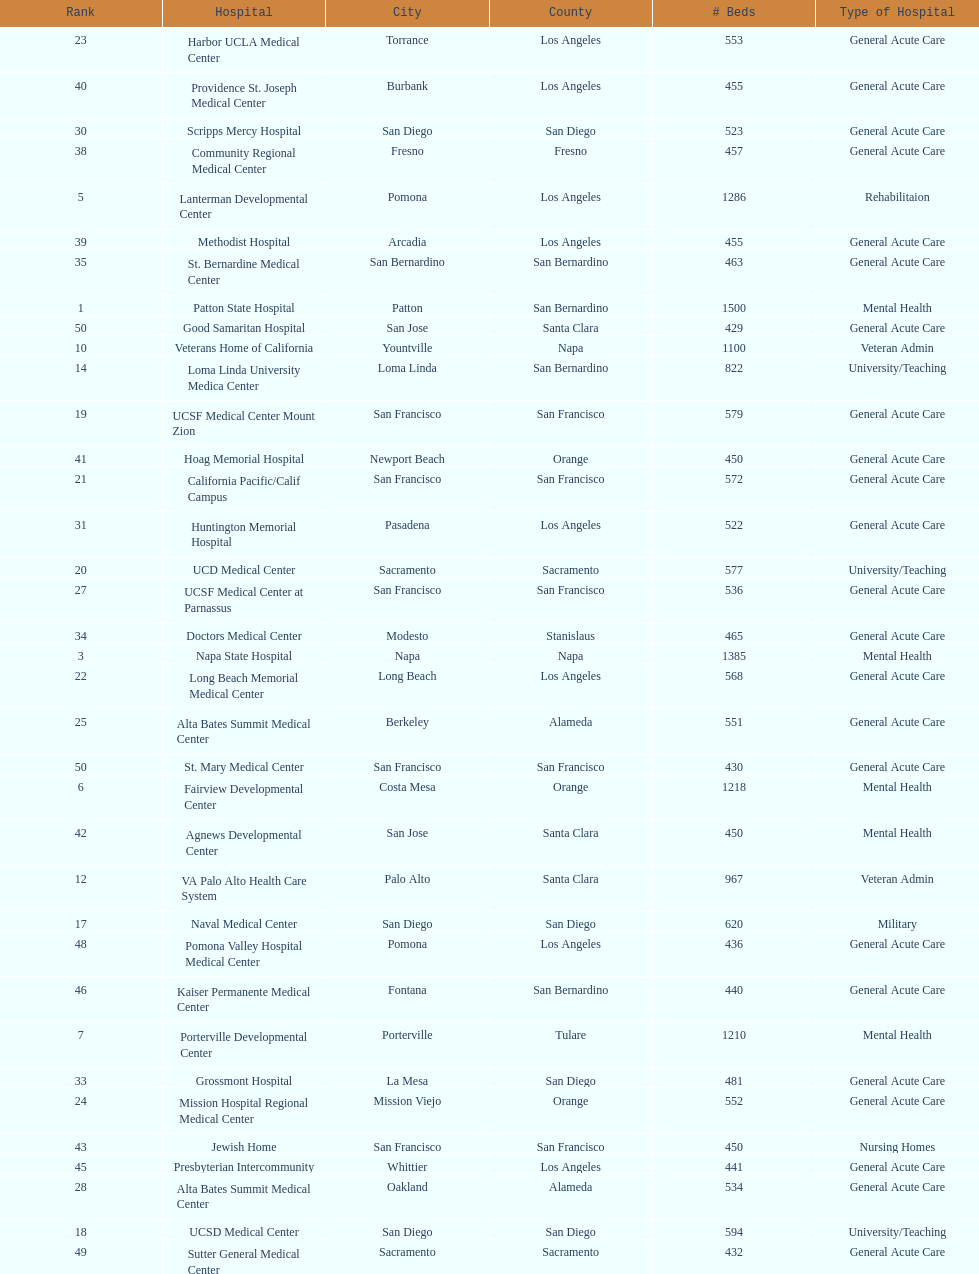Could you parse the entire table as a dict? {'header': ['Rank', 'Hospital', 'City', 'County', '# Beds', 'Type of Hospital'], 'rows': [['23', 'Harbor UCLA Medical Center', 'Torrance', 'Los Angeles', '553', 'General Acute Care'], ['40', 'Providence St. Joseph Medical Center', 'Burbank', 'Los Angeles', '455', 'General Acute Care'], ['30', 'Scripps Mercy Hospital', 'San Diego', 'San Diego', '523', 'General Acute Care'], ['38', 'Community Regional Medical Center', 'Fresno', 'Fresno', '457', 'General Acute Care'], ['5', 'Lanterman Developmental Center', 'Pomona', 'Los Angeles', '1286', 'Rehabilitaion'], ['39', 'Methodist Hospital', 'Arcadia', 'Los Angeles', '455', 'General Acute Care'], ['35', 'St. Bernardine Medical Center', 'San Bernardino', 'San Bernardino', '463', 'General Acute Care'], ['1', 'Patton State Hospital', 'Patton', 'San Bernardino', '1500', 'Mental Health'], ['50', 'Good Samaritan Hospital', 'San Jose', 'Santa Clara', '429', 'General Acute Care'], ['10', 'Veterans Home of California', 'Yountville', 'Napa', '1100', 'Veteran Admin'], ['14', 'Loma Linda University Medica Center', 'Loma Linda', 'San Bernardino', '822', 'University/Teaching'], ['19', 'UCSF Medical Center Mount Zion', 'San Francisco', 'San Francisco', '579', 'General Acute Care'], ['41', 'Hoag Memorial Hospital', 'Newport Beach', 'Orange', '450', 'General Acute Care'], ['21', 'California Pacific/Calif Campus', 'San Francisco', 'San Francisco', '572', 'General Acute Care'], ['31', 'Huntington Memorial Hospital', 'Pasadena', 'Los Angeles', '522', 'General Acute Care'], ['20', 'UCD Medical Center', 'Sacramento', 'Sacramento', '577', 'University/Teaching'], ['27', 'UCSF Medical Center at Parnassus', 'San Francisco', 'San Francisco', '536', 'General Acute Care'], ['34', 'Doctors Medical Center', 'Modesto', 'Stanislaus', '465', 'General Acute Care'], ['3', 'Napa State Hospital', 'Napa', 'Napa', '1385', 'Mental Health'], ['22', 'Long Beach Memorial Medical Center', 'Long Beach', 'Los Angeles', '568', 'General Acute Care'], ['25', 'Alta Bates Summit Medical Center', 'Berkeley', 'Alameda', '551', 'General Acute Care'], ['50', 'St. Mary Medical Center', 'San Francisco', 'San Francisco', '430', 'General Acute Care'], ['6', 'Fairview Developmental Center', 'Costa Mesa', 'Orange', '1218', 'Mental Health'], ['42', 'Agnews Developmental Center', 'San Jose', 'Santa Clara', '450', 'Mental Health'], ['12', 'VA Palo Alto Health Care System', 'Palo Alto', 'Santa Clara', '967', 'Veteran Admin'], ['17', 'Naval Medical Center', 'San Diego', 'San Diego', '620', 'Military'], ['48', 'Pomona Valley Hospital Medical Center', 'Pomona', 'Los Angeles', '436', 'General Acute Care'], ['46', 'Kaiser Permanente Medical Center', 'Fontana', 'San Bernardino', '440', 'General Acute Care'], ['7', 'Porterville Developmental Center', 'Porterville', 'Tulare', '1210', 'Mental Health'], ['33', 'Grossmont Hospital', 'La Mesa', 'San Diego', '481', 'General Acute Care'], ['24', 'Mission Hospital Regional Medical Center', 'Mission Viejo', 'Orange', '552', 'General Acute Care'], ['43', 'Jewish Home', 'San Francisco', 'San Francisco', '450', 'Nursing Homes'], ['45', 'Presbyterian Intercommunity', 'Whittier', 'Los Angeles', '441', 'General Acute Care'], ['28', 'Alta Bates Summit Medical Center', 'Oakland', 'Alameda', '534', 'General Acute Care'], ['18', 'UCSD Medical Center', 'San Diego', 'San Diego', '594', 'University/Teaching'], ['49', 'Sutter General Medical Center', 'Sacramento', 'Sacramento', '432', 'General Acute Care'], ['29', 'Santa Clara Valley Medical Center', 'San Jose', 'Santa Clara', '524', 'General Acute Care'], ['16', 'Kaweah Delta Regional Medical Center', 'Visalia', 'Tulare', '629', 'General Acute Care'], ['2', 'LA County & USC Medical Center', 'Los Angeles', 'Los Angeles', '1395', 'General Acute Care'], ['9', 'Atascadero State Hospital', 'Atascadero', 'San Luis Obispo', '1200', 'Mental Health'], ['37', 'Stanford Medical Center', 'Stanford', 'Santa Clara', '460', 'General Acute Care'], ['32', 'Adventist Medical Center', 'Glendale', 'Los Angeles', '508', 'General Acute Care'], ['26', 'San Francisco General Hospital', 'San Francisco', 'San Francisco', '550', 'General Acute Care'], ['47', 'Kaiser Permanente Medical Center', 'Los Angeles', 'Los Angeles', '439', 'General Acute Care'], ['8', 'Laguna Honda Hospital Rehabilitation Center', 'San Francisco', 'San Francisco', '1200', 'Nursing Homes'], ['36', 'UCI Medical Center', 'Orange', 'Orange', '462', 'General Acute Care'], ['11', 'Metropolitan State Hospital', 'Norwalk', 'Los Angeles', '1096', 'Mental Health'], ['13', 'Cedars-Sinai Medical Center', 'West Hollywood', 'Los Angeles', '952', 'General Acute Care'], ['4', 'Sonoma Developmental Center', 'Eldridge', 'Sonoma', '1300', 'Mental Health'], ['15', 'UCLA Medical Center', 'Los Angeles', 'Los Angeles', '668', 'General Acute Care'], ['44', 'St. Joseph Hospital Orange', 'Orange', 'Orange', '448', 'General Acute Care']]} What hospital in los angeles county providing hospital beds specifically for rehabilitation is ranked at least among the top 10 hospitals? Lanterman Developmental Center. 